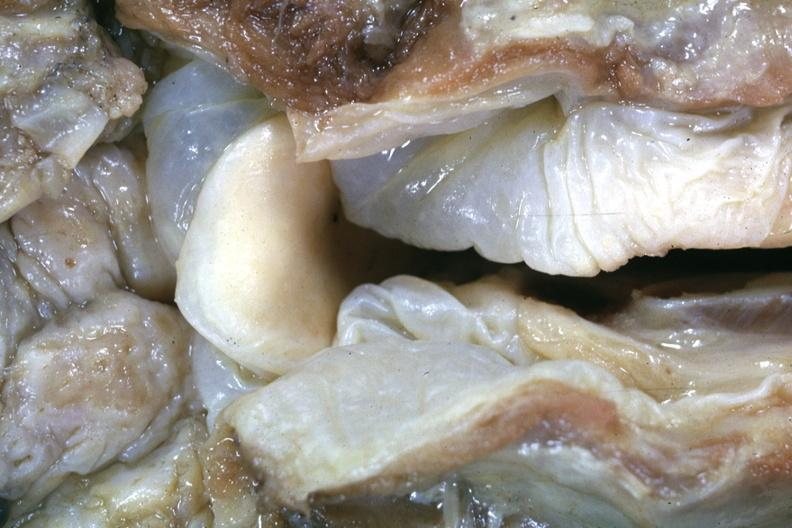what is a very good example of a lesion seldom seen at autopsy slide?
Answer the question using a single word or phrase. This 